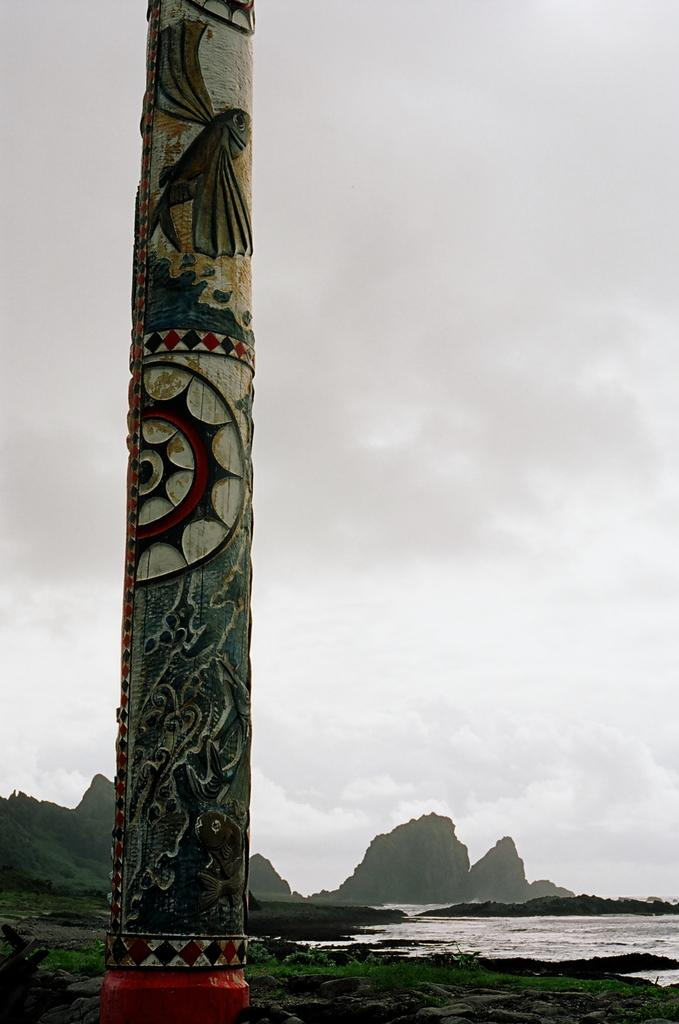What structure can be seen in the image? There is a pillar in the image. What is located on the right side of the image? There is a water body on the right side of the image. What can be seen in the background of the image? There are hills and trees in the background of the image. How would you describe the sky in the image? The sky is cloudy in the image. What type of beast can be seen wearing a sweater in the image? There is no beast or sweater present in the image. What dish is served on the plate in the image? There is no plate present in the image. 